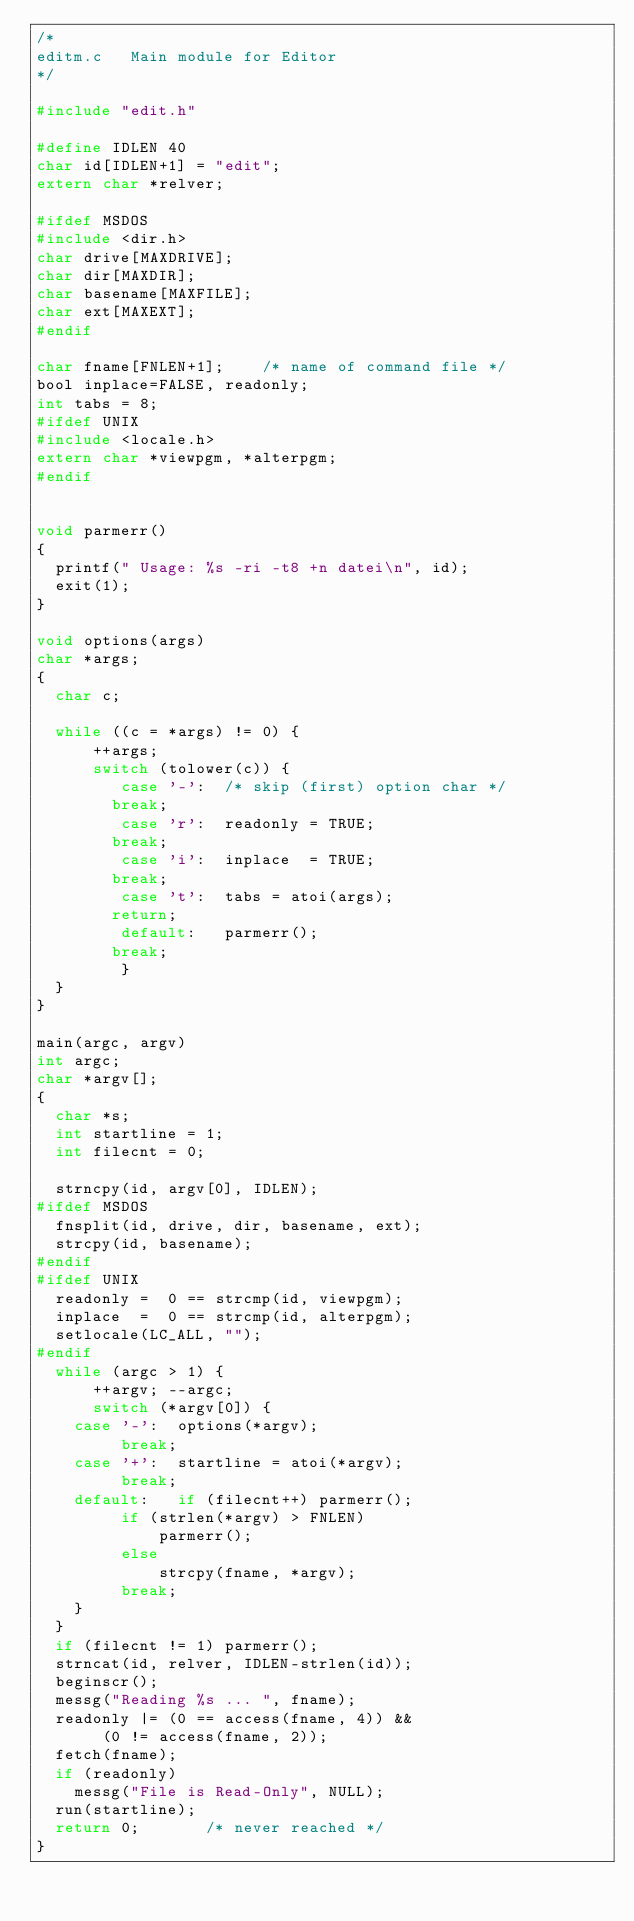<code> <loc_0><loc_0><loc_500><loc_500><_C_>/*
editm.c   Main module for Editor
*/

#include "edit.h"

#define IDLEN 40
char id[IDLEN+1] = "edit";
extern char *relver;

#ifdef MSDOS
#include <dir.h>
char drive[MAXDRIVE];
char dir[MAXDIR];
char basename[MAXFILE];
char ext[MAXEXT];
#endif

char fname[FNLEN+1];    /* name of command file */
bool inplace=FALSE, readonly;
int tabs = 8;
#ifdef UNIX
#include <locale.h>
extern char *viewpgm, *alterpgm;
#endif


void parmerr()
{
	printf(" Usage: %s -ri -t8 +n datei\n", id);
	exit(1);
}

void options(args)
char *args;
{
	char c;

	while ((c = *args) != 0) {
	    ++args;
	    switch (tolower(c)) {
	       case '-':  /* skip (first) option char */
			  break;
	       case 'r':  readonly = TRUE;
			  break;
	       case 'i':  inplace  = TRUE;
			  break;
	       case 't':  tabs = atoi(args);
			  return;
	       default:   parmerr();
			  break;
	       }
	}
}

main(argc, argv)
int argc;
char *argv[];
{
	char *s;
	int startline = 1;
	int filecnt = 0;

	strncpy(id, argv[0], IDLEN);
#ifdef MSDOS
	fnsplit(id, drive, dir, basename, ext);
	strcpy(id, basename);
#endif
#ifdef UNIX
	readonly =  0 == strcmp(id, viewpgm);
	inplace  =  0 == strcmp(id, alterpgm);
	setlocale(LC_ALL, "");
#endif
	while (argc > 1) {
	    ++argv; --argc;
	    switch (*argv[0]) {
		case '-':  options(*argv);
			   break;
		case '+':  startline = atoi(*argv);
			   break;
		default:   if (filecnt++) parmerr();
			   if (strlen(*argv) > FNLEN)
			       parmerr();
			   else
			       strcpy(fname, *argv);
			   break;
		}
	}
	if (filecnt != 1) parmerr();
	strncat(id, relver, IDLEN-strlen(id));
	beginscr();
	messg("Reading %s ... ", fname);
	readonly |= (0 == access(fname, 4)) &&
		   (0 != access(fname, 2));
	fetch(fname);
	if (readonly)
		messg("File is Read-Only", NULL);
	run(startline);
	return 0;       /* never reached */
}
</code> 